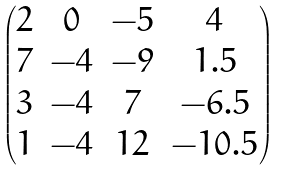Convert formula to latex. <formula><loc_0><loc_0><loc_500><loc_500>\begin{pmatrix} 2 & 0 & - 5 & 4 \\ 7 & - 4 & - 9 & 1 . 5 \\ 3 & - 4 & 7 & - 6 . 5 \\ 1 & - 4 & 1 2 & - 1 0 . 5 \end{pmatrix}</formula> 